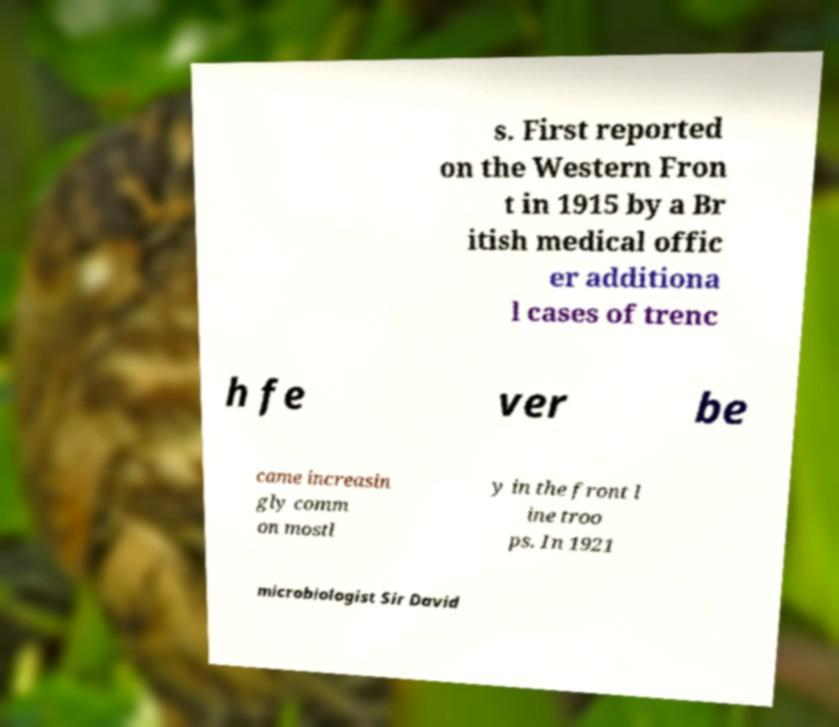Can you accurately transcribe the text from the provided image for me? s. First reported on the Western Fron t in 1915 by a Br itish medical offic er additiona l cases of trenc h fe ver be came increasin gly comm on mostl y in the front l ine troo ps. In 1921 microbiologist Sir David 